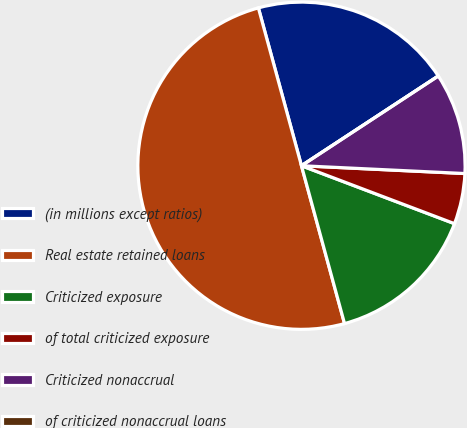<chart> <loc_0><loc_0><loc_500><loc_500><pie_chart><fcel>(in millions except ratios)<fcel>Real estate retained loans<fcel>Criticized exposure<fcel>of total criticized exposure<fcel>Criticized nonaccrual<fcel>of criticized nonaccrual loans<nl><fcel>20.0%<fcel>50.0%<fcel>15.0%<fcel>5.0%<fcel>10.0%<fcel>0.0%<nl></chart> 